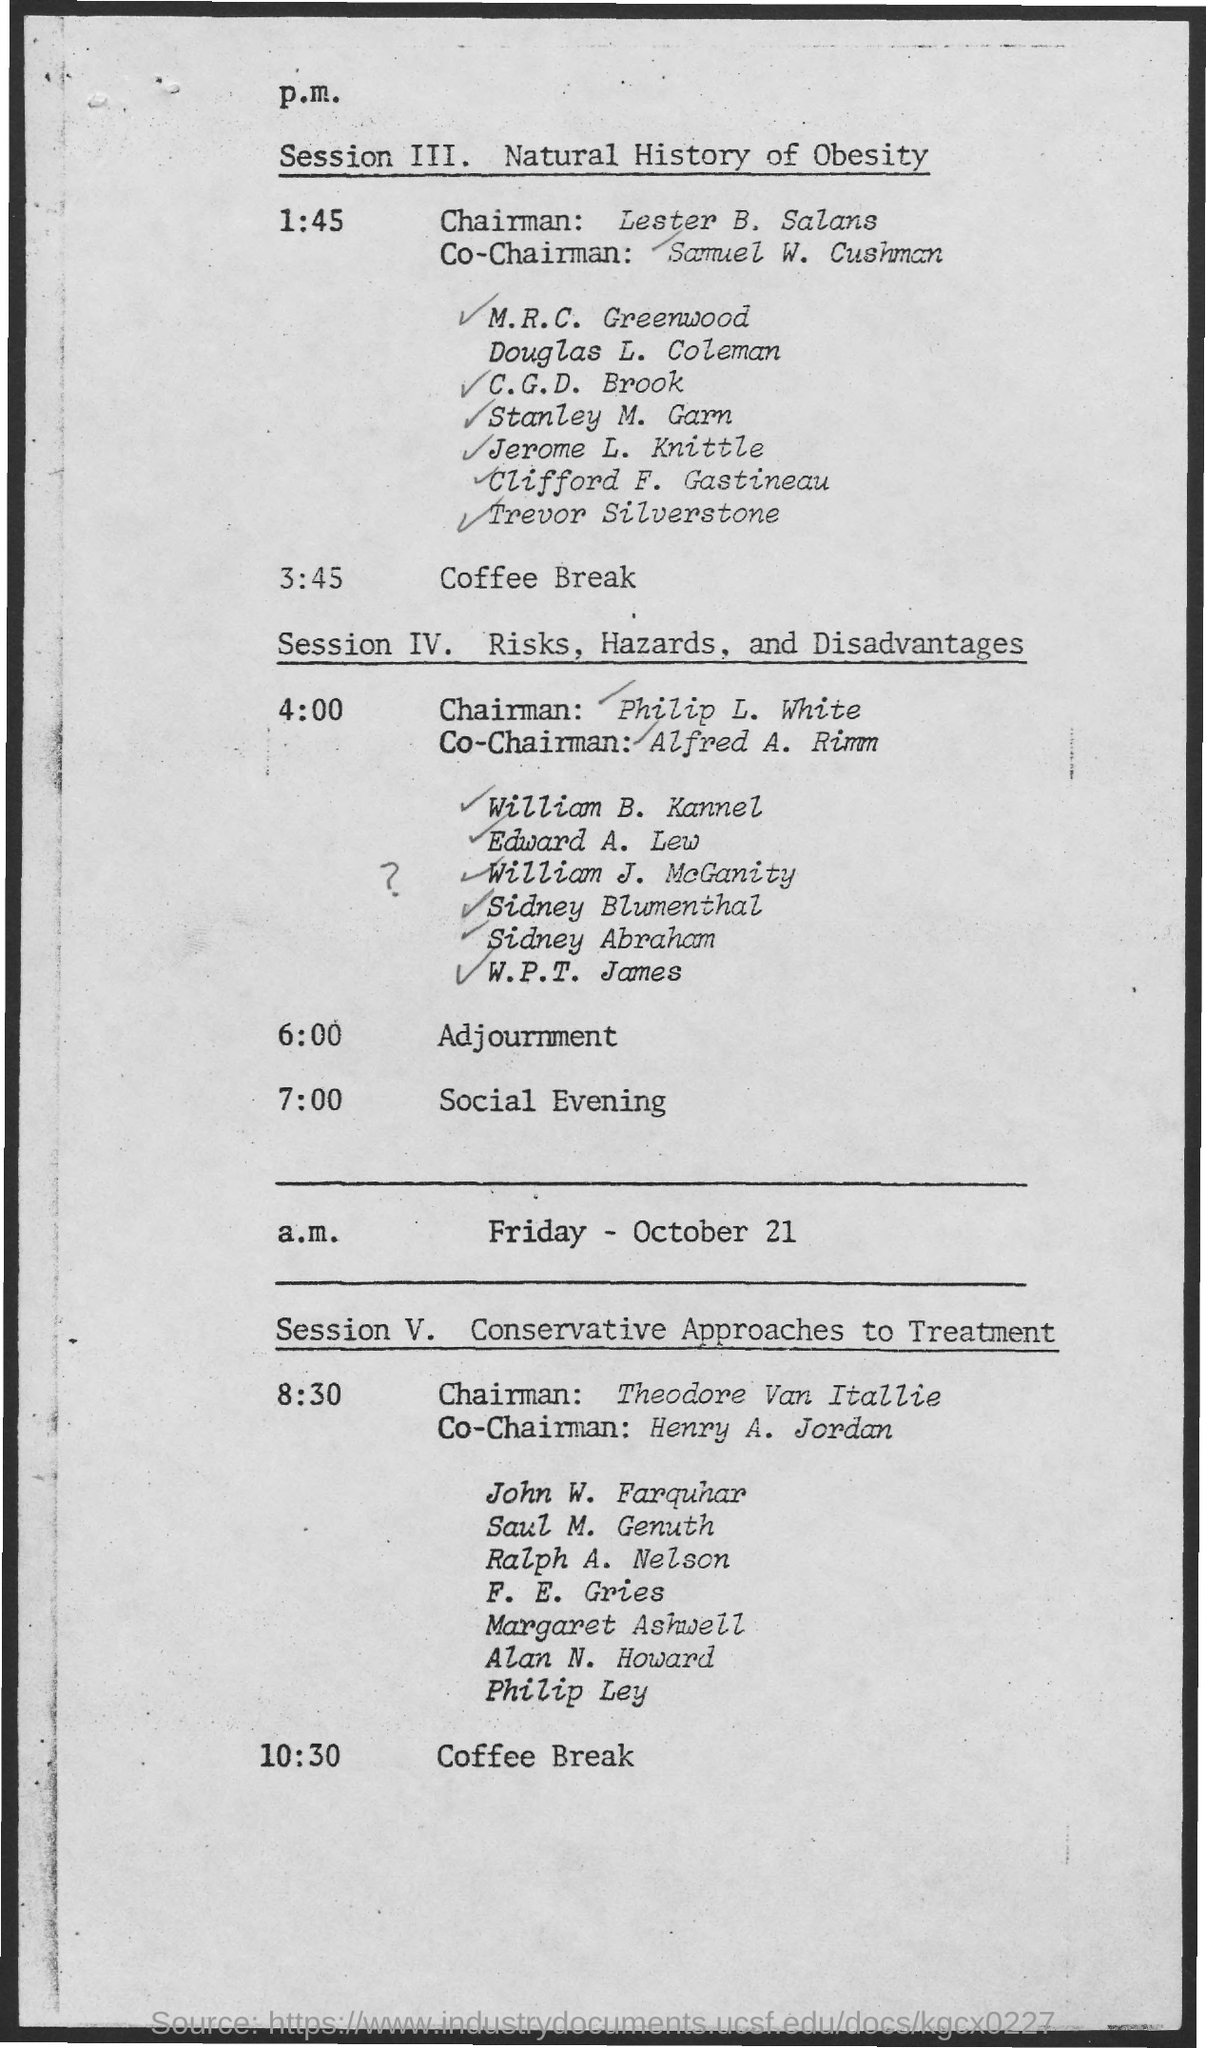Who is the Chairman for Session ɪɪɪ.?
Provide a succinct answer. Lester b. salans. Who is the Co-Chairman for Session ɪɪɪ.?
Ensure brevity in your answer.  Samuel W. Cushman. What does Session IV.  discuss about?
Provide a succinct answer. Risks, hazards, and disadvantages. What does Session V. discuss about?
Provide a succinct answer. Conservative approaches to treatment. Who is the Co-Chairman for Session V.?
Provide a short and direct response. Henry A. Jordan. 